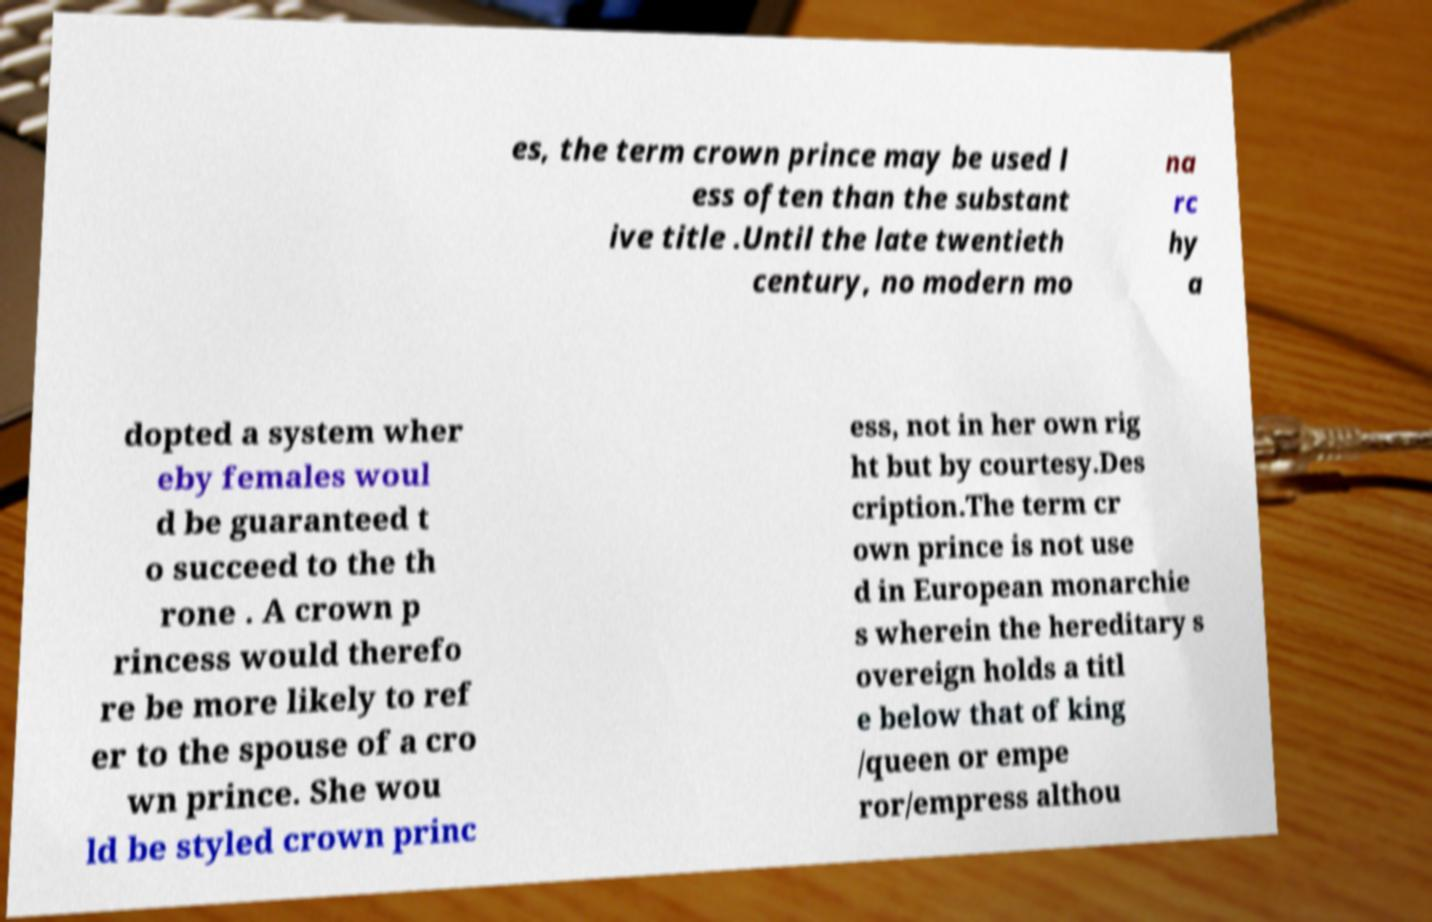What messages or text are displayed in this image? I need them in a readable, typed format. es, the term crown prince may be used l ess often than the substant ive title .Until the late twentieth century, no modern mo na rc hy a dopted a system wher eby females woul d be guaranteed t o succeed to the th rone . A crown p rincess would therefo re be more likely to ref er to the spouse of a cro wn prince. She wou ld be styled crown princ ess, not in her own rig ht but by courtesy.Des cription.The term cr own prince is not use d in European monarchie s wherein the hereditary s overeign holds a titl e below that of king /queen or empe ror/empress althou 